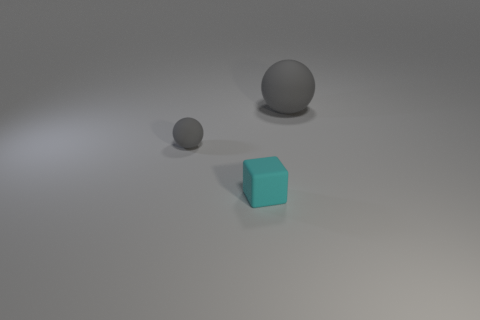There is a object that is in front of the small gray ball; is its size the same as the gray ball that is to the left of the small cube?
Give a very brief answer. Yes. What number of big objects are either gray rubber cylinders or cyan matte objects?
Your answer should be very brief. 0. How many things are both in front of the large matte ball and behind the rubber cube?
Ensure brevity in your answer.  1. Does the large thing have the same material as the gray thing to the left of the large gray matte ball?
Make the answer very short. Yes. What number of cyan things are big rubber spheres or small matte things?
Provide a succinct answer. 1. Is there a gray rubber ball that has the same size as the cyan object?
Your response must be concise. Yes. What material is the sphere to the left of the tiny matte object that is right of the gray ball in front of the big gray matte sphere made of?
Offer a very short reply. Rubber. Are there an equal number of gray objects behind the big rubber thing and yellow rubber blocks?
Offer a terse response. Yes. Does the gray ball that is right of the cyan cube have the same material as the gray ball that is on the left side of the small cyan thing?
Ensure brevity in your answer.  Yes. How many objects are purple metallic balls or gray spheres on the left side of the cyan matte thing?
Ensure brevity in your answer.  1. 